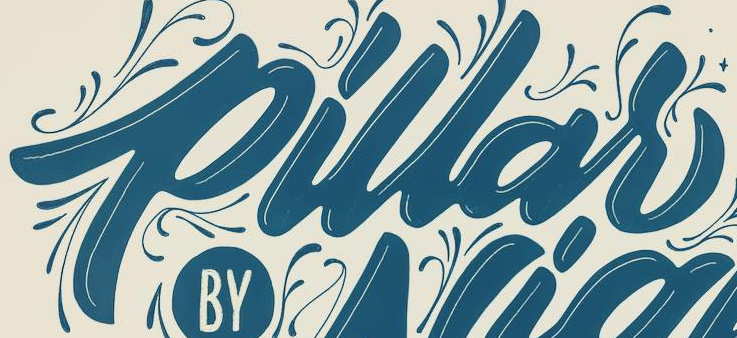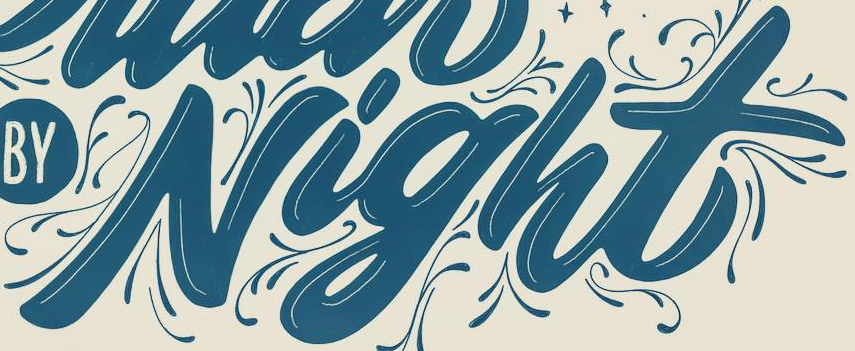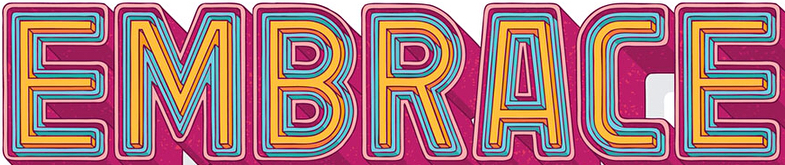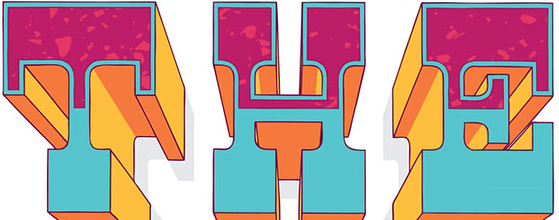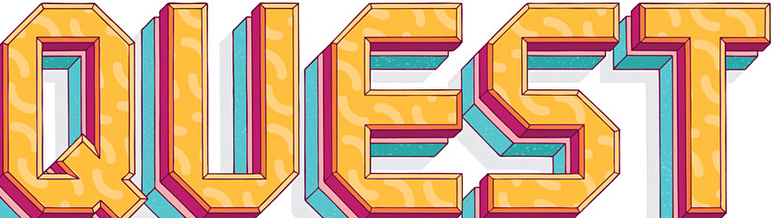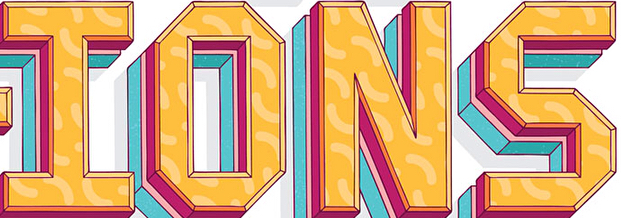Read the text from these images in sequence, separated by a semicolon. pillar; Night; EMBRACE; THE; QUEST; IONS 